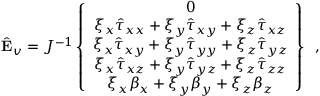<formula> <loc_0><loc_0><loc_500><loc_500>\hat { E } _ { v } = J ^ { - 1 } \left \{ \begin{array} { c } { 0 } \\ { \xi _ { x } \hat { \tau } _ { x x } + \xi _ { y } \hat { \tau } _ { x y } + \xi _ { z } \hat { \tau } _ { x z } } \\ { \xi _ { x } \hat { \tau } _ { x y } + \xi _ { y } \hat { \tau } _ { y y } + \xi _ { z } \hat { \tau } _ { y z } } \\ { \xi _ { x } \hat { \tau } _ { x z } + \xi _ { y } \hat { \tau } _ { y z } + \xi _ { z } \hat { \tau } _ { z z } } \\ { \xi _ { x } { \beta } _ { x } + \xi _ { y } { \beta } _ { y } + \xi _ { z } { \beta } _ { z } } \end{array} \right \} \, ,</formula> 